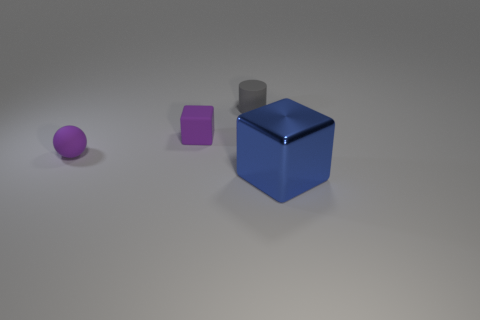Is there any other thing that is the same material as the blue object?
Keep it short and to the point. No. How many other things are the same size as the blue cube?
Your response must be concise. 0. There is a rubber cube that is the same color as the small ball; what size is it?
Keep it short and to the point. Small. Are there any small cylinders that have the same material as the tiny cube?
Your answer should be compact. Yes. There is a block that is behind the blue object; is there a matte thing on the left side of it?
Give a very brief answer. Yes. What is the material of the block on the left side of the blue block?
Make the answer very short. Rubber. There is a cube that is behind the big blue cube that is in front of the cube that is on the left side of the large blue metallic object; what is its color?
Keep it short and to the point. Purple. How many other tiny things have the same shape as the blue shiny object?
Your answer should be very brief. 1. There is a matte thing that is on the left side of the cube behind the big metallic block; what size is it?
Keep it short and to the point. Small. Do the matte cylinder and the ball have the same size?
Make the answer very short. Yes. 